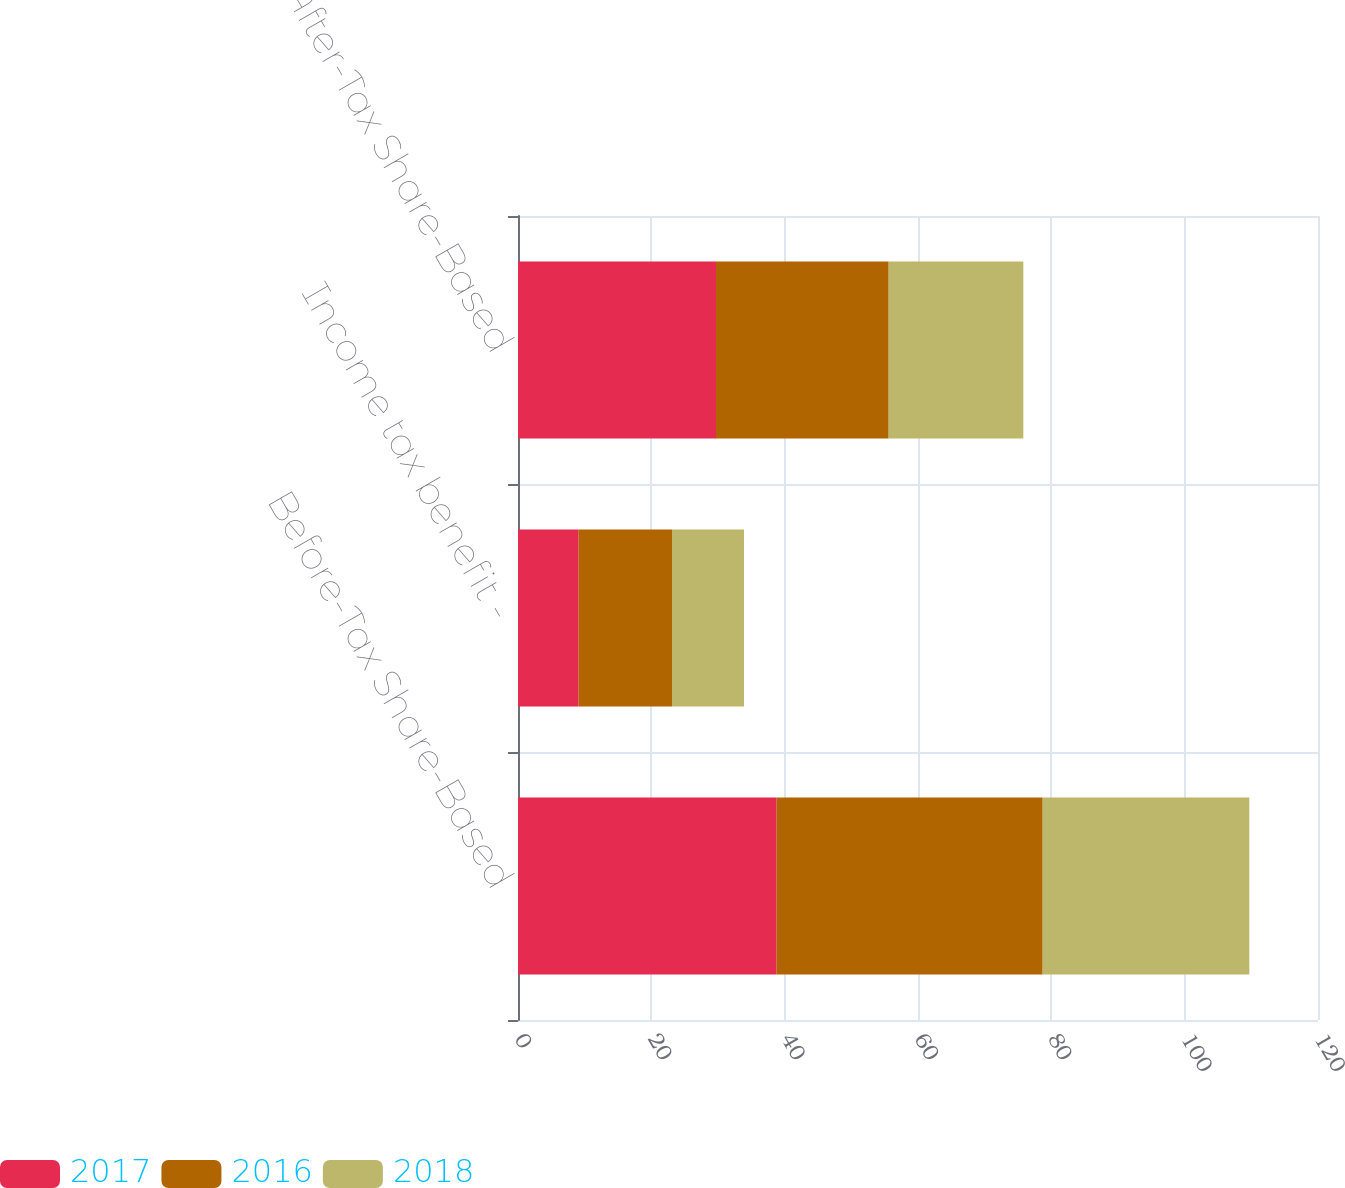Convert chart. <chart><loc_0><loc_0><loc_500><loc_500><stacked_bar_chart><ecel><fcel>Before-Tax Share-Based<fcel>Income tax benefit -<fcel>After-Tax Share-Based<nl><fcel>2017<fcel>38.8<fcel>9.1<fcel>29.7<nl><fcel>2016<fcel>39.9<fcel>14<fcel>25.9<nl><fcel>2018<fcel>31<fcel>10.8<fcel>20.2<nl></chart> 